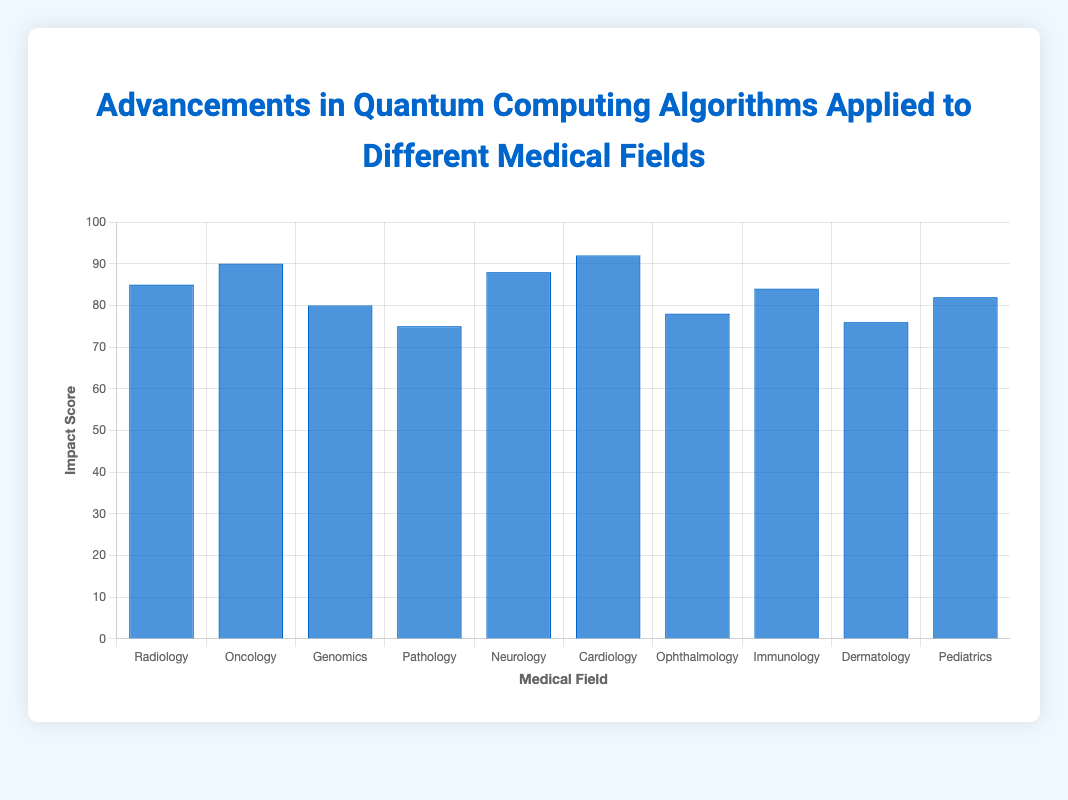Which medical field has the highest impact score? The highest bar on the chart indicates the maximum impact score. Cardiology has a bar reaching an impact score of 92.
Answer: Cardiology What is the impact score difference between Neurology and Radiology? The height of the Neurology bar is at 88, and the Radiology bar is at 85. Subtracting the two values: 88 - 85 = 3.
Answer: 3 Which medical field had advancements in 2020, and what are their impact scores? By referencing the tooltip information that shows the year of advancements, Genomics and Ophthalmology had advancements in 2020. Their impact scores are 80 and 78 respectively as indicated by the height of their bars.
Answer: Genomics: 80, Ophthalmology: 78 What is the average impact score of advancements made in 2021? Advancements in 2021 are in Radiology, Pathology, and Pediatrics with impact scores of 85, 75, and 82 respectively. The average is calculated as (85 + 75 + 82) / 3 = 242 / 3.
Answer: 80.67 Which medical field has the second highest impact score and what is the application? Oncology is the second-highest with an impact score of 90. Referring to the tooltip, the application for Oncology is Tumor Detection.
Answer: Oncology: Tumor Detection How many medical fields have an impact score greater than 80? By visually inspecting the heights of the bars, medical fields with impact scores greater than 80 are Radiology (85), Oncology (90), Neurology (88), Cardiology (92), Immunology (84), and Pediatrics (82). Counting these fields gives 6.
Answer: 6 Which two fields have the closest impact scores, and what are the scores? The closest impact scores by visual comparison are Dermatology (76) and Pathology (75), with only a 1 point difference.
Answer: Dermatology: 76, Pathology: 75 Rank the medical fields in order of their impact scores from highest to lowest. The heights of the bars can be compared to list the impact scores from highest to lowest: Cardiology (92), Oncology (90), Neurology (88), Radiology (85), Immunology (84), Pediatrics (82), Genomics (80), Ophthalmology (78), Dermatology (76), Pathology (75).
Answer: Cardiology, Oncology, Neurology, Radiology, Immunology, Pediatrics, Genomics, Ophthalmology, Dermatology, Pathology 